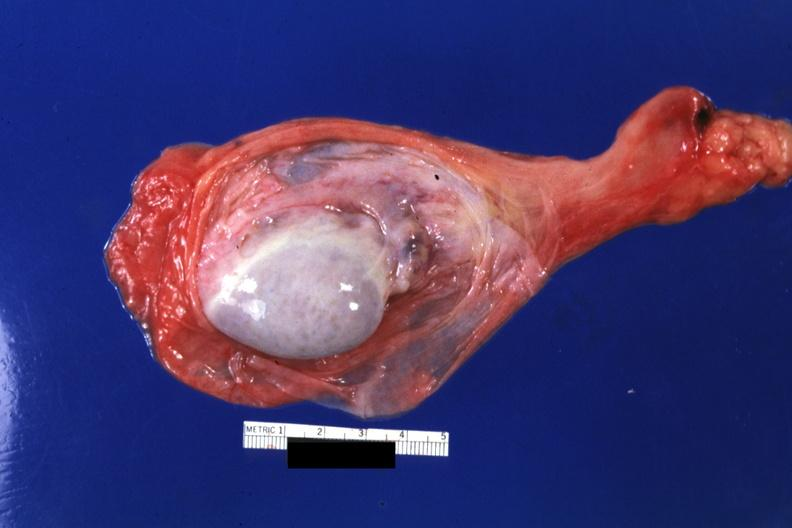what opened?
Answer the question using a single word or phrase. Sac 